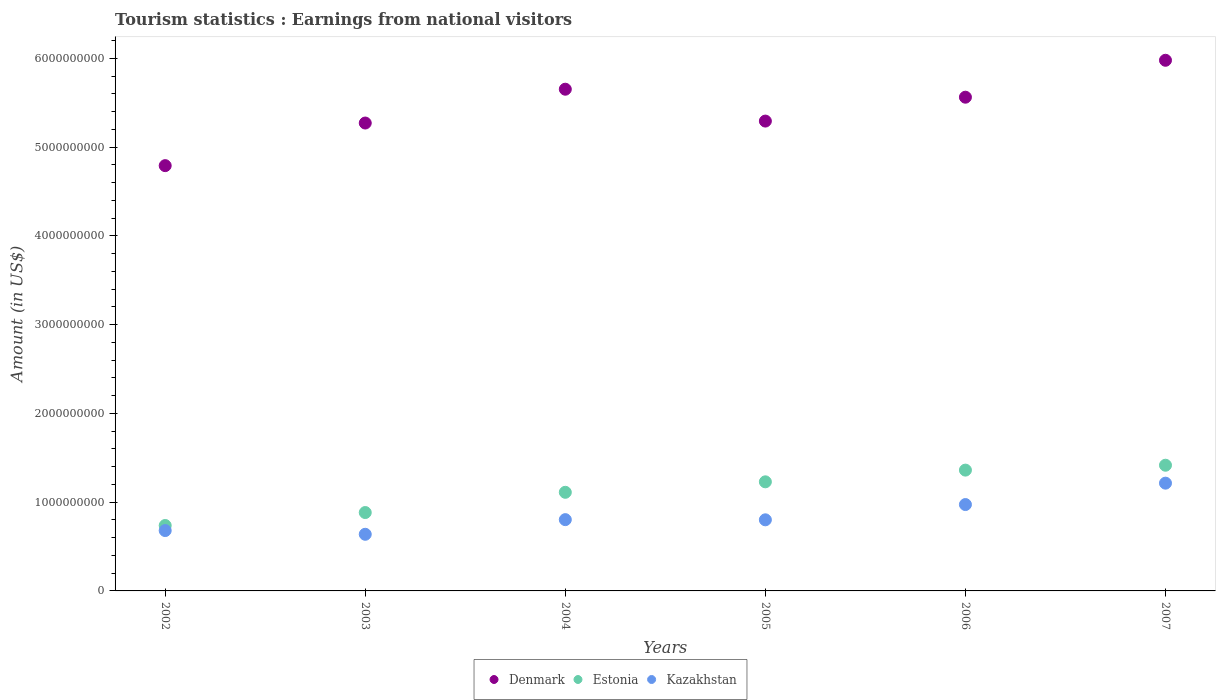What is the earnings from national visitors in Kazakhstan in 2004?
Offer a terse response. 8.03e+08. Across all years, what is the maximum earnings from national visitors in Kazakhstan?
Give a very brief answer. 1.21e+09. Across all years, what is the minimum earnings from national visitors in Denmark?
Your answer should be compact. 4.79e+09. In which year was the earnings from national visitors in Estonia maximum?
Your response must be concise. 2007. What is the total earnings from national visitors in Estonia in the graph?
Provide a succinct answer. 6.74e+09. What is the difference between the earnings from national visitors in Denmark in 2002 and that in 2007?
Make the answer very short. -1.19e+09. What is the difference between the earnings from national visitors in Denmark in 2004 and the earnings from national visitors in Kazakhstan in 2003?
Keep it short and to the point. 5.01e+09. What is the average earnings from national visitors in Denmark per year?
Make the answer very short. 5.42e+09. In the year 2005, what is the difference between the earnings from national visitors in Denmark and earnings from national visitors in Kazakhstan?
Provide a succinct answer. 4.49e+09. In how many years, is the earnings from national visitors in Denmark greater than 3600000000 US$?
Keep it short and to the point. 6. What is the ratio of the earnings from national visitors in Kazakhstan in 2003 to that in 2004?
Give a very brief answer. 0.79. What is the difference between the highest and the second highest earnings from national visitors in Denmark?
Provide a succinct answer. 3.26e+08. What is the difference between the highest and the lowest earnings from national visitors in Kazakhstan?
Keep it short and to the point. 5.76e+08. Is it the case that in every year, the sum of the earnings from national visitors in Estonia and earnings from national visitors in Denmark  is greater than the earnings from national visitors in Kazakhstan?
Ensure brevity in your answer.  Yes. Does the earnings from national visitors in Kazakhstan monotonically increase over the years?
Give a very brief answer. No. Is the earnings from national visitors in Denmark strictly greater than the earnings from national visitors in Kazakhstan over the years?
Your answer should be compact. Yes. Is the earnings from national visitors in Estonia strictly less than the earnings from national visitors in Denmark over the years?
Ensure brevity in your answer.  Yes. How many dotlines are there?
Offer a very short reply. 3. What is the difference between two consecutive major ticks on the Y-axis?
Your response must be concise. 1.00e+09. Are the values on the major ticks of Y-axis written in scientific E-notation?
Offer a very short reply. No. Does the graph contain any zero values?
Ensure brevity in your answer.  No. Does the graph contain grids?
Provide a succinct answer. No. How are the legend labels stacked?
Ensure brevity in your answer.  Horizontal. What is the title of the graph?
Offer a very short reply. Tourism statistics : Earnings from national visitors. What is the label or title of the Y-axis?
Your response must be concise. Amount (in US$). What is the Amount (in US$) of Denmark in 2002?
Give a very brief answer. 4.79e+09. What is the Amount (in US$) in Estonia in 2002?
Give a very brief answer. 7.37e+08. What is the Amount (in US$) in Kazakhstan in 2002?
Offer a terse response. 6.80e+08. What is the Amount (in US$) of Denmark in 2003?
Your answer should be very brief. 5.27e+09. What is the Amount (in US$) of Estonia in 2003?
Your response must be concise. 8.83e+08. What is the Amount (in US$) of Kazakhstan in 2003?
Your answer should be very brief. 6.38e+08. What is the Amount (in US$) in Denmark in 2004?
Your answer should be compact. 5.65e+09. What is the Amount (in US$) of Estonia in 2004?
Your answer should be very brief. 1.11e+09. What is the Amount (in US$) in Kazakhstan in 2004?
Your answer should be very brief. 8.03e+08. What is the Amount (in US$) of Denmark in 2005?
Keep it short and to the point. 5.29e+09. What is the Amount (in US$) in Estonia in 2005?
Offer a very short reply. 1.23e+09. What is the Amount (in US$) in Kazakhstan in 2005?
Make the answer very short. 8.01e+08. What is the Amount (in US$) of Denmark in 2006?
Give a very brief answer. 5.56e+09. What is the Amount (in US$) of Estonia in 2006?
Give a very brief answer. 1.36e+09. What is the Amount (in US$) of Kazakhstan in 2006?
Offer a very short reply. 9.73e+08. What is the Amount (in US$) in Denmark in 2007?
Make the answer very short. 5.98e+09. What is the Amount (in US$) of Estonia in 2007?
Offer a very short reply. 1.42e+09. What is the Amount (in US$) in Kazakhstan in 2007?
Your response must be concise. 1.21e+09. Across all years, what is the maximum Amount (in US$) in Denmark?
Offer a terse response. 5.98e+09. Across all years, what is the maximum Amount (in US$) of Estonia?
Offer a terse response. 1.42e+09. Across all years, what is the maximum Amount (in US$) in Kazakhstan?
Make the answer very short. 1.21e+09. Across all years, what is the minimum Amount (in US$) of Denmark?
Offer a terse response. 4.79e+09. Across all years, what is the minimum Amount (in US$) in Estonia?
Your answer should be very brief. 7.37e+08. Across all years, what is the minimum Amount (in US$) of Kazakhstan?
Offer a very short reply. 6.38e+08. What is the total Amount (in US$) of Denmark in the graph?
Your answer should be very brief. 3.25e+1. What is the total Amount (in US$) of Estonia in the graph?
Provide a succinct answer. 6.74e+09. What is the total Amount (in US$) of Kazakhstan in the graph?
Your answer should be compact. 5.11e+09. What is the difference between the Amount (in US$) of Denmark in 2002 and that in 2003?
Make the answer very short. -4.80e+08. What is the difference between the Amount (in US$) of Estonia in 2002 and that in 2003?
Ensure brevity in your answer.  -1.46e+08. What is the difference between the Amount (in US$) in Kazakhstan in 2002 and that in 2003?
Give a very brief answer. 4.20e+07. What is the difference between the Amount (in US$) in Denmark in 2002 and that in 2004?
Make the answer very short. -8.61e+08. What is the difference between the Amount (in US$) in Estonia in 2002 and that in 2004?
Keep it short and to the point. -3.74e+08. What is the difference between the Amount (in US$) of Kazakhstan in 2002 and that in 2004?
Give a very brief answer. -1.23e+08. What is the difference between the Amount (in US$) of Denmark in 2002 and that in 2005?
Your response must be concise. -5.02e+08. What is the difference between the Amount (in US$) in Estonia in 2002 and that in 2005?
Give a very brief answer. -4.92e+08. What is the difference between the Amount (in US$) in Kazakhstan in 2002 and that in 2005?
Your answer should be compact. -1.21e+08. What is the difference between the Amount (in US$) of Denmark in 2002 and that in 2006?
Your answer should be compact. -7.71e+08. What is the difference between the Amount (in US$) in Estonia in 2002 and that in 2006?
Offer a very short reply. -6.24e+08. What is the difference between the Amount (in US$) of Kazakhstan in 2002 and that in 2006?
Keep it short and to the point. -2.93e+08. What is the difference between the Amount (in US$) in Denmark in 2002 and that in 2007?
Make the answer very short. -1.19e+09. What is the difference between the Amount (in US$) in Estonia in 2002 and that in 2007?
Ensure brevity in your answer.  -6.79e+08. What is the difference between the Amount (in US$) of Kazakhstan in 2002 and that in 2007?
Your answer should be compact. -5.34e+08. What is the difference between the Amount (in US$) in Denmark in 2003 and that in 2004?
Your answer should be compact. -3.81e+08. What is the difference between the Amount (in US$) in Estonia in 2003 and that in 2004?
Offer a terse response. -2.28e+08. What is the difference between the Amount (in US$) of Kazakhstan in 2003 and that in 2004?
Offer a very short reply. -1.65e+08. What is the difference between the Amount (in US$) of Denmark in 2003 and that in 2005?
Offer a very short reply. -2.20e+07. What is the difference between the Amount (in US$) in Estonia in 2003 and that in 2005?
Give a very brief answer. -3.46e+08. What is the difference between the Amount (in US$) in Kazakhstan in 2003 and that in 2005?
Offer a very short reply. -1.63e+08. What is the difference between the Amount (in US$) in Denmark in 2003 and that in 2006?
Offer a very short reply. -2.91e+08. What is the difference between the Amount (in US$) in Estonia in 2003 and that in 2006?
Provide a short and direct response. -4.78e+08. What is the difference between the Amount (in US$) of Kazakhstan in 2003 and that in 2006?
Your answer should be compact. -3.35e+08. What is the difference between the Amount (in US$) in Denmark in 2003 and that in 2007?
Your response must be concise. -7.07e+08. What is the difference between the Amount (in US$) of Estonia in 2003 and that in 2007?
Offer a very short reply. -5.33e+08. What is the difference between the Amount (in US$) in Kazakhstan in 2003 and that in 2007?
Make the answer very short. -5.76e+08. What is the difference between the Amount (in US$) in Denmark in 2004 and that in 2005?
Offer a very short reply. 3.59e+08. What is the difference between the Amount (in US$) of Estonia in 2004 and that in 2005?
Ensure brevity in your answer.  -1.18e+08. What is the difference between the Amount (in US$) of Kazakhstan in 2004 and that in 2005?
Make the answer very short. 2.00e+06. What is the difference between the Amount (in US$) in Denmark in 2004 and that in 2006?
Offer a terse response. 9.00e+07. What is the difference between the Amount (in US$) of Estonia in 2004 and that in 2006?
Your answer should be very brief. -2.50e+08. What is the difference between the Amount (in US$) of Kazakhstan in 2004 and that in 2006?
Make the answer very short. -1.70e+08. What is the difference between the Amount (in US$) of Denmark in 2004 and that in 2007?
Your response must be concise. -3.26e+08. What is the difference between the Amount (in US$) in Estonia in 2004 and that in 2007?
Your answer should be very brief. -3.05e+08. What is the difference between the Amount (in US$) of Kazakhstan in 2004 and that in 2007?
Give a very brief answer. -4.11e+08. What is the difference between the Amount (in US$) of Denmark in 2005 and that in 2006?
Make the answer very short. -2.69e+08. What is the difference between the Amount (in US$) in Estonia in 2005 and that in 2006?
Offer a very short reply. -1.32e+08. What is the difference between the Amount (in US$) in Kazakhstan in 2005 and that in 2006?
Provide a short and direct response. -1.72e+08. What is the difference between the Amount (in US$) of Denmark in 2005 and that in 2007?
Your answer should be very brief. -6.85e+08. What is the difference between the Amount (in US$) in Estonia in 2005 and that in 2007?
Make the answer very short. -1.87e+08. What is the difference between the Amount (in US$) of Kazakhstan in 2005 and that in 2007?
Provide a succinct answer. -4.13e+08. What is the difference between the Amount (in US$) of Denmark in 2006 and that in 2007?
Offer a terse response. -4.16e+08. What is the difference between the Amount (in US$) in Estonia in 2006 and that in 2007?
Keep it short and to the point. -5.50e+07. What is the difference between the Amount (in US$) in Kazakhstan in 2006 and that in 2007?
Provide a succinct answer. -2.41e+08. What is the difference between the Amount (in US$) in Denmark in 2002 and the Amount (in US$) in Estonia in 2003?
Provide a succinct answer. 3.91e+09. What is the difference between the Amount (in US$) of Denmark in 2002 and the Amount (in US$) of Kazakhstan in 2003?
Your answer should be very brief. 4.15e+09. What is the difference between the Amount (in US$) of Estonia in 2002 and the Amount (in US$) of Kazakhstan in 2003?
Your answer should be very brief. 9.90e+07. What is the difference between the Amount (in US$) of Denmark in 2002 and the Amount (in US$) of Estonia in 2004?
Your answer should be compact. 3.68e+09. What is the difference between the Amount (in US$) of Denmark in 2002 and the Amount (in US$) of Kazakhstan in 2004?
Provide a short and direct response. 3.99e+09. What is the difference between the Amount (in US$) of Estonia in 2002 and the Amount (in US$) of Kazakhstan in 2004?
Offer a terse response. -6.60e+07. What is the difference between the Amount (in US$) in Denmark in 2002 and the Amount (in US$) in Estonia in 2005?
Your answer should be compact. 3.56e+09. What is the difference between the Amount (in US$) in Denmark in 2002 and the Amount (in US$) in Kazakhstan in 2005?
Your response must be concise. 3.99e+09. What is the difference between the Amount (in US$) in Estonia in 2002 and the Amount (in US$) in Kazakhstan in 2005?
Offer a very short reply. -6.40e+07. What is the difference between the Amount (in US$) in Denmark in 2002 and the Amount (in US$) in Estonia in 2006?
Your response must be concise. 3.43e+09. What is the difference between the Amount (in US$) in Denmark in 2002 and the Amount (in US$) in Kazakhstan in 2006?
Give a very brief answer. 3.82e+09. What is the difference between the Amount (in US$) of Estonia in 2002 and the Amount (in US$) of Kazakhstan in 2006?
Provide a succinct answer. -2.36e+08. What is the difference between the Amount (in US$) of Denmark in 2002 and the Amount (in US$) of Estonia in 2007?
Provide a succinct answer. 3.38e+09. What is the difference between the Amount (in US$) of Denmark in 2002 and the Amount (in US$) of Kazakhstan in 2007?
Your answer should be compact. 3.58e+09. What is the difference between the Amount (in US$) of Estonia in 2002 and the Amount (in US$) of Kazakhstan in 2007?
Your answer should be compact. -4.77e+08. What is the difference between the Amount (in US$) in Denmark in 2003 and the Amount (in US$) in Estonia in 2004?
Offer a terse response. 4.16e+09. What is the difference between the Amount (in US$) in Denmark in 2003 and the Amount (in US$) in Kazakhstan in 2004?
Your response must be concise. 4.47e+09. What is the difference between the Amount (in US$) of Estonia in 2003 and the Amount (in US$) of Kazakhstan in 2004?
Keep it short and to the point. 8.00e+07. What is the difference between the Amount (in US$) in Denmark in 2003 and the Amount (in US$) in Estonia in 2005?
Your response must be concise. 4.04e+09. What is the difference between the Amount (in US$) in Denmark in 2003 and the Amount (in US$) in Kazakhstan in 2005?
Offer a terse response. 4.47e+09. What is the difference between the Amount (in US$) in Estonia in 2003 and the Amount (in US$) in Kazakhstan in 2005?
Give a very brief answer. 8.20e+07. What is the difference between the Amount (in US$) in Denmark in 2003 and the Amount (in US$) in Estonia in 2006?
Your answer should be compact. 3.91e+09. What is the difference between the Amount (in US$) in Denmark in 2003 and the Amount (in US$) in Kazakhstan in 2006?
Provide a succinct answer. 4.30e+09. What is the difference between the Amount (in US$) in Estonia in 2003 and the Amount (in US$) in Kazakhstan in 2006?
Your response must be concise. -9.00e+07. What is the difference between the Amount (in US$) in Denmark in 2003 and the Amount (in US$) in Estonia in 2007?
Your answer should be very brief. 3.86e+09. What is the difference between the Amount (in US$) in Denmark in 2003 and the Amount (in US$) in Kazakhstan in 2007?
Provide a succinct answer. 4.06e+09. What is the difference between the Amount (in US$) of Estonia in 2003 and the Amount (in US$) of Kazakhstan in 2007?
Make the answer very short. -3.31e+08. What is the difference between the Amount (in US$) in Denmark in 2004 and the Amount (in US$) in Estonia in 2005?
Make the answer very short. 4.42e+09. What is the difference between the Amount (in US$) in Denmark in 2004 and the Amount (in US$) in Kazakhstan in 2005?
Offer a terse response. 4.85e+09. What is the difference between the Amount (in US$) of Estonia in 2004 and the Amount (in US$) of Kazakhstan in 2005?
Offer a terse response. 3.10e+08. What is the difference between the Amount (in US$) of Denmark in 2004 and the Amount (in US$) of Estonia in 2006?
Provide a succinct answer. 4.29e+09. What is the difference between the Amount (in US$) of Denmark in 2004 and the Amount (in US$) of Kazakhstan in 2006?
Offer a terse response. 4.68e+09. What is the difference between the Amount (in US$) in Estonia in 2004 and the Amount (in US$) in Kazakhstan in 2006?
Provide a succinct answer. 1.38e+08. What is the difference between the Amount (in US$) in Denmark in 2004 and the Amount (in US$) in Estonia in 2007?
Your response must be concise. 4.24e+09. What is the difference between the Amount (in US$) of Denmark in 2004 and the Amount (in US$) of Kazakhstan in 2007?
Offer a terse response. 4.44e+09. What is the difference between the Amount (in US$) in Estonia in 2004 and the Amount (in US$) in Kazakhstan in 2007?
Your answer should be very brief. -1.03e+08. What is the difference between the Amount (in US$) of Denmark in 2005 and the Amount (in US$) of Estonia in 2006?
Give a very brief answer. 3.93e+09. What is the difference between the Amount (in US$) of Denmark in 2005 and the Amount (in US$) of Kazakhstan in 2006?
Offer a very short reply. 4.32e+09. What is the difference between the Amount (in US$) of Estonia in 2005 and the Amount (in US$) of Kazakhstan in 2006?
Offer a very short reply. 2.56e+08. What is the difference between the Amount (in US$) in Denmark in 2005 and the Amount (in US$) in Estonia in 2007?
Provide a succinct answer. 3.88e+09. What is the difference between the Amount (in US$) of Denmark in 2005 and the Amount (in US$) of Kazakhstan in 2007?
Your answer should be very brief. 4.08e+09. What is the difference between the Amount (in US$) of Estonia in 2005 and the Amount (in US$) of Kazakhstan in 2007?
Give a very brief answer. 1.50e+07. What is the difference between the Amount (in US$) in Denmark in 2006 and the Amount (in US$) in Estonia in 2007?
Make the answer very short. 4.15e+09. What is the difference between the Amount (in US$) of Denmark in 2006 and the Amount (in US$) of Kazakhstan in 2007?
Make the answer very short. 4.35e+09. What is the difference between the Amount (in US$) in Estonia in 2006 and the Amount (in US$) in Kazakhstan in 2007?
Make the answer very short. 1.47e+08. What is the average Amount (in US$) in Denmark per year?
Provide a succinct answer. 5.42e+09. What is the average Amount (in US$) in Estonia per year?
Your response must be concise. 1.12e+09. What is the average Amount (in US$) in Kazakhstan per year?
Your response must be concise. 8.52e+08. In the year 2002, what is the difference between the Amount (in US$) of Denmark and Amount (in US$) of Estonia?
Ensure brevity in your answer.  4.05e+09. In the year 2002, what is the difference between the Amount (in US$) in Denmark and Amount (in US$) in Kazakhstan?
Your answer should be compact. 4.11e+09. In the year 2002, what is the difference between the Amount (in US$) of Estonia and Amount (in US$) of Kazakhstan?
Provide a succinct answer. 5.70e+07. In the year 2003, what is the difference between the Amount (in US$) of Denmark and Amount (in US$) of Estonia?
Your response must be concise. 4.39e+09. In the year 2003, what is the difference between the Amount (in US$) in Denmark and Amount (in US$) in Kazakhstan?
Offer a very short reply. 4.63e+09. In the year 2003, what is the difference between the Amount (in US$) of Estonia and Amount (in US$) of Kazakhstan?
Your response must be concise. 2.45e+08. In the year 2004, what is the difference between the Amount (in US$) in Denmark and Amount (in US$) in Estonia?
Your answer should be very brief. 4.54e+09. In the year 2004, what is the difference between the Amount (in US$) in Denmark and Amount (in US$) in Kazakhstan?
Your response must be concise. 4.85e+09. In the year 2004, what is the difference between the Amount (in US$) of Estonia and Amount (in US$) of Kazakhstan?
Ensure brevity in your answer.  3.08e+08. In the year 2005, what is the difference between the Amount (in US$) of Denmark and Amount (in US$) of Estonia?
Keep it short and to the point. 4.06e+09. In the year 2005, what is the difference between the Amount (in US$) of Denmark and Amount (in US$) of Kazakhstan?
Give a very brief answer. 4.49e+09. In the year 2005, what is the difference between the Amount (in US$) in Estonia and Amount (in US$) in Kazakhstan?
Keep it short and to the point. 4.28e+08. In the year 2006, what is the difference between the Amount (in US$) in Denmark and Amount (in US$) in Estonia?
Provide a succinct answer. 4.20e+09. In the year 2006, what is the difference between the Amount (in US$) in Denmark and Amount (in US$) in Kazakhstan?
Ensure brevity in your answer.  4.59e+09. In the year 2006, what is the difference between the Amount (in US$) of Estonia and Amount (in US$) of Kazakhstan?
Provide a short and direct response. 3.88e+08. In the year 2007, what is the difference between the Amount (in US$) in Denmark and Amount (in US$) in Estonia?
Keep it short and to the point. 4.56e+09. In the year 2007, what is the difference between the Amount (in US$) in Denmark and Amount (in US$) in Kazakhstan?
Your answer should be compact. 4.76e+09. In the year 2007, what is the difference between the Amount (in US$) of Estonia and Amount (in US$) of Kazakhstan?
Keep it short and to the point. 2.02e+08. What is the ratio of the Amount (in US$) of Denmark in 2002 to that in 2003?
Give a very brief answer. 0.91. What is the ratio of the Amount (in US$) in Estonia in 2002 to that in 2003?
Keep it short and to the point. 0.83. What is the ratio of the Amount (in US$) in Kazakhstan in 2002 to that in 2003?
Offer a very short reply. 1.07. What is the ratio of the Amount (in US$) of Denmark in 2002 to that in 2004?
Ensure brevity in your answer.  0.85. What is the ratio of the Amount (in US$) in Estonia in 2002 to that in 2004?
Make the answer very short. 0.66. What is the ratio of the Amount (in US$) in Kazakhstan in 2002 to that in 2004?
Provide a short and direct response. 0.85. What is the ratio of the Amount (in US$) in Denmark in 2002 to that in 2005?
Your answer should be compact. 0.91. What is the ratio of the Amount (in US$) of Estonia in 2002 to that in 2005?
Provide a succinct answer. 0.6. What is the ratio of the Amount (in US$) of Kazakhstan in 2002 to that in 2005?
Offer a very short reply. 0.85. What is the ratio of the Amount (in US$) in Denmark in 2002 to that in 2006?
Your answer should be compact. 0.86. What is the ratio of the Amount (in US$) of Estonia in 2002 to that in 2006?
Provide a short and direct response. 0.54. What is the ratio of the Amount (in US$) of Kazakhstan in 2002 to that in 2006?
Provide a succinct answer. 0.7. What is the ratio of the Amount (in US$) in Denmark in 2002 to that in 2007?
Keep it short and to the point. 0.8. What is the ratio of the Amount (in US$) in Estonia in 2002 to that in 2007?
Provide a short and direct response. 0.52. What is the ratio of the Amount (in US$) of Kazakhstan in 2002 to that in 2007?
Your response must be concise. 0.56. What is the ratio of the Amount (in US$) of Denmark in 2003 to that in 2004?
Offer a very short reply. 0.93. What is the ratio of the Amount (in US$) of Estonia in 2003 to that in 2004?
Ensure brevity in your answer.  0.79. What is the ratio of the Amount (in US$) of Kazakhstan in 2003 to that in 2004?
Keep it short and to the point. 0.79. What is the ratio of the Amount (in US$) of Estonia in 2003 to that in 2005?
Your answer should be very brief. 0.72. What is the ratio of the Amount (in US$) in Kazakhstan in 2003 to that in 2005?
Your answer should be very brief. 0.8. What is the ratio of the Amount (in US$) of Denmark in 2003 to that in 2006?
Give a very brief answer. 0.95. What is the ratio of the Amount (in US$) in Estonia in 2003 to that in 2006?
Your answer should be compact. 0.65. What is the ratio of the Amount (in US$) of Kazakhstan in 2003 to that in 2006?
Ensure brevity in your answer.  0.66. What is the ratio of the Amount (in US$) in Denmark in 2003 to that in 2007?
Offer a terse response. 0.88. What is the ratio of the Amount (in US$) of Estonia in 2003 to that in 2007?
Offer a very short reply. 0.62. What is the ratio of the Amount (in US$) in Kazakhstan in 2003 to that in 2007?
Give a very brief answer. 0.53. What is the ratio of the Amount (in US$) in Denmark in 2004 to that in 2005?
Provide a short and direct response. 1.07. What is the ratio of the Amount (in US$) in Estonia in 2004 to that in 2005?
Your answer should be compact. 0.9. What is the ratio of the Amount (in US$) of Denmark in 2004 to that in 2006?
Offer a terse response. 1.02. What is the ratio of the Amount (in US$) in Estonia in 2004 to that in 2006?
Provide a short and direct response. 0.82. What is the ratio of the Amount (in US$) in Kazakhstan in 2004 to that in 2006?
Your answer should be very brief. 0.83. What is the ratio of the Amount (in US$) in Denmark in 2004 to that in 2007?
Your answer should be compact. 0.95. What is the ratio of the Amount (in US$) in Estonia in 2004 to that in 2007?
Provide a short and direct response. 0.78. What is the ratio of the Amount (in US$) of Kazakhstan in 2004 to that in 2007?
Provide a short and direct response. 0.66. What is the ratio of the Amount (in US$) of Denmark in 2005 to that in 2006?
Ensure brevity in your answer.  0.95. What is the ratio of the Amount (in US$) in Estonia in 2005 to that in 2006?
Give a very brief answer. 0.9. What is the ratio of the Amount (in US$) of Kazakhstan in 2005 to that in 2006?
Offer a very short reply. 0.82. What is the ratio of the Amount (in US$) in Denmark in 2005 to that in 2007?
Make the answer very short. 0.89. What is the ratio of the Amount (in US$) in Estonia in 2005 to that in 2007?
Offer a very short reply. 0.87. What is the ratio of the Amount (in US$) of Kazakhstan in 2005 to that in 2007?
Your response must be concise. 0.66. What is the ratio of the Amount (in US$) of Denmark in 2006 to that in 2007?
Provide a short and direct response. 0.93. What is the ratio of the Amount (in US$) of Estonia in 2006 to that in 2007?
Ensure brevity in your answer.  0.96. What is the ratio of the Amount (in US$) of Kazakhstan in 2006 to that in 2007?
Give a very brief answer. 0.8. What is the difference between the highest and the second highest Amount (in US$) of Denmark?
Offer a very short reply. 3.26e+08. What is the difference between the highest and the second highest Amount (in US$) of Estonia?
Give a very brief answer. 5.50e+07. What is the difference between the highest and the second highest Amount (in US$) in Kazakhstan?
Your response must be concise. 2.41e+08. What is the difference between the highest and the lowest Amount (in US$) of Denmark?
Ensure brevity in your answer.  1.19e+09. What is the difference between the highest and the lowest Amount (in US$) of Estonia?
Your response must be concise. 6.79e+08. What is the difference between the highest and the lowest Amount (in US$) in Kazakhstan?
Your answer should be very brief. 5.76e+08. 